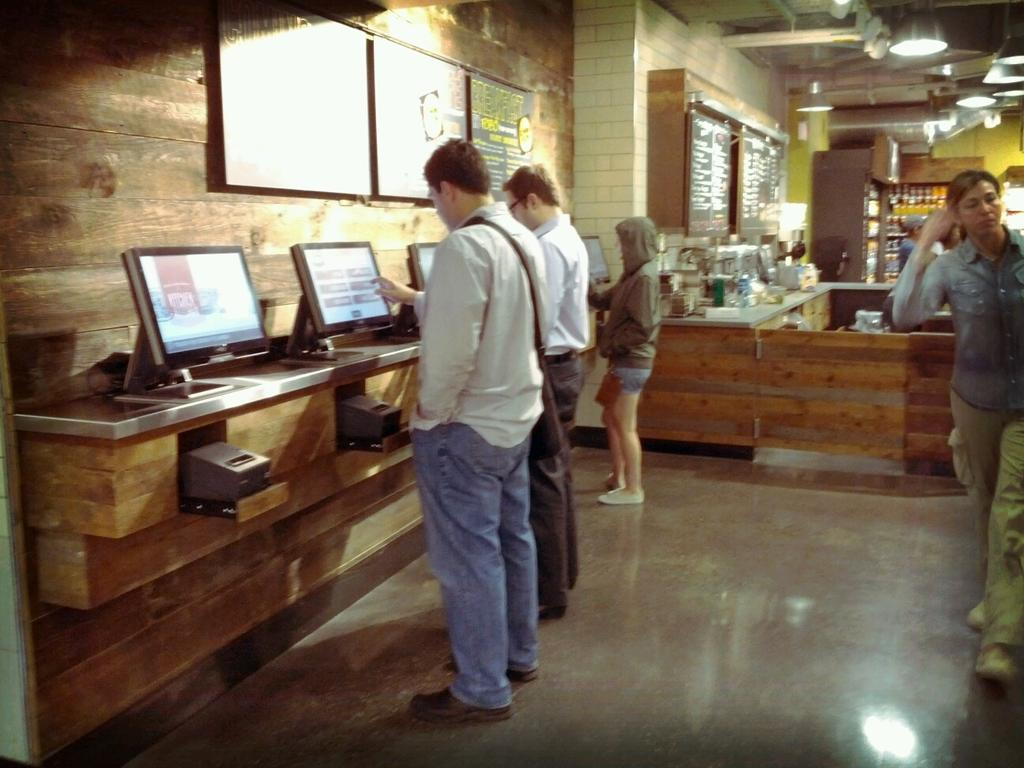What is happening in the image? There are people standing in the image. Where are the people standing? The people are standing on the floor. What objects can be seen on a table in the image? There are monitors on a table in the image. What is on the wall in the image? There are blackboards on the wall in the image. How many ducks are being cooked by the people in the image? There are no ducks present in the image, and the people are not cooking anything. 